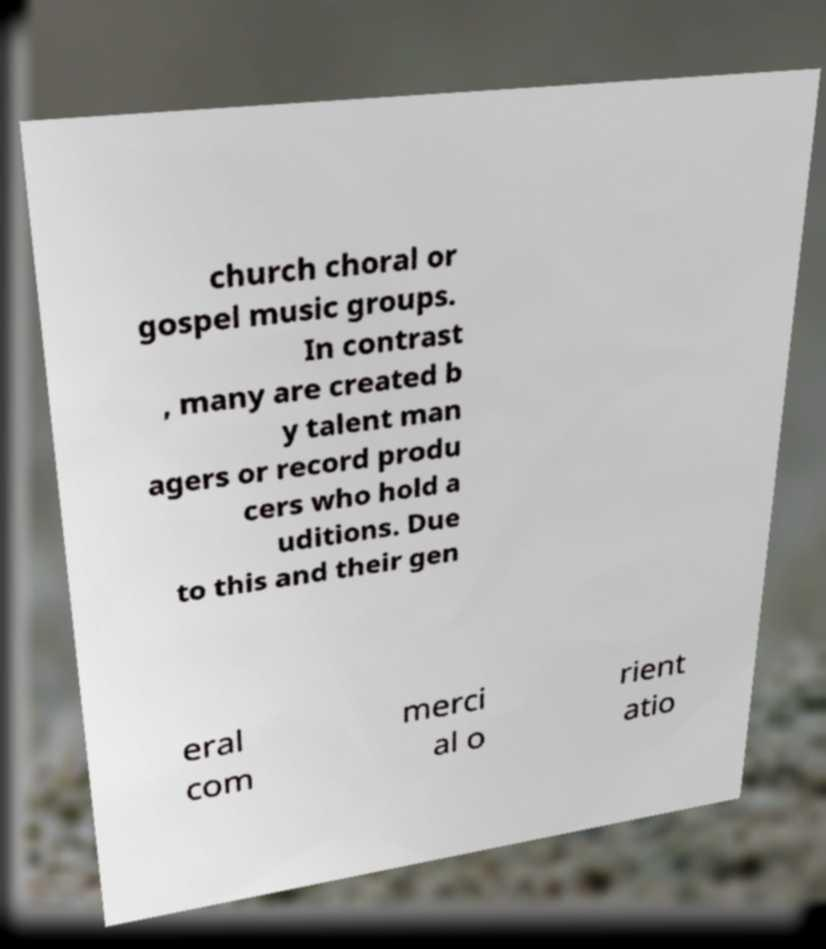Please read and relay the text visible in this image. What does it say? church choral or gospel music groups. In contrast , many are created b y talent man agers or record produ cers who hold a uditions. Due to this and their gen eral com merci al o rient atio 